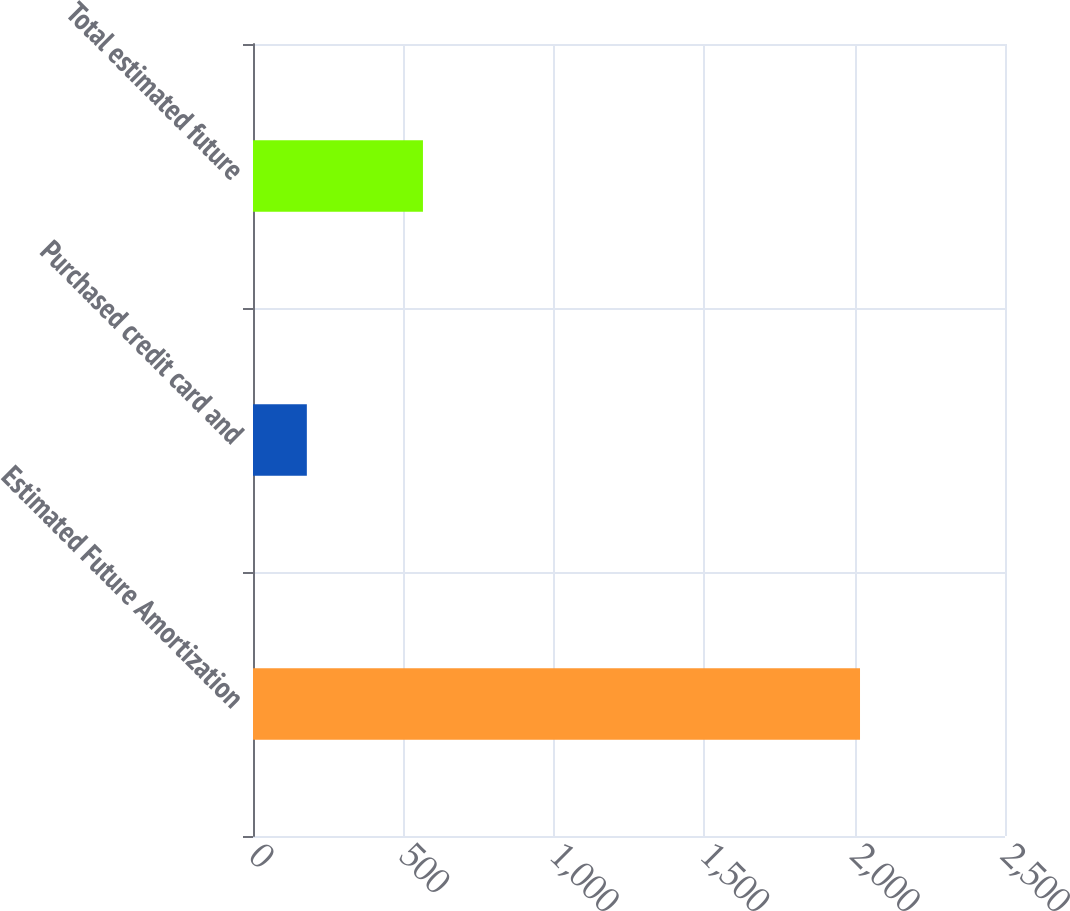Convert chart. <chart><loc_0><loc_0><loc_500><loc_500><bar_chart><fcel>Estimated Future Amortization<fcel>Purchased credit card and<fcel>Total estimated future<nl><fcel>2018<fcel>179<fcel>565<nl></chart> 